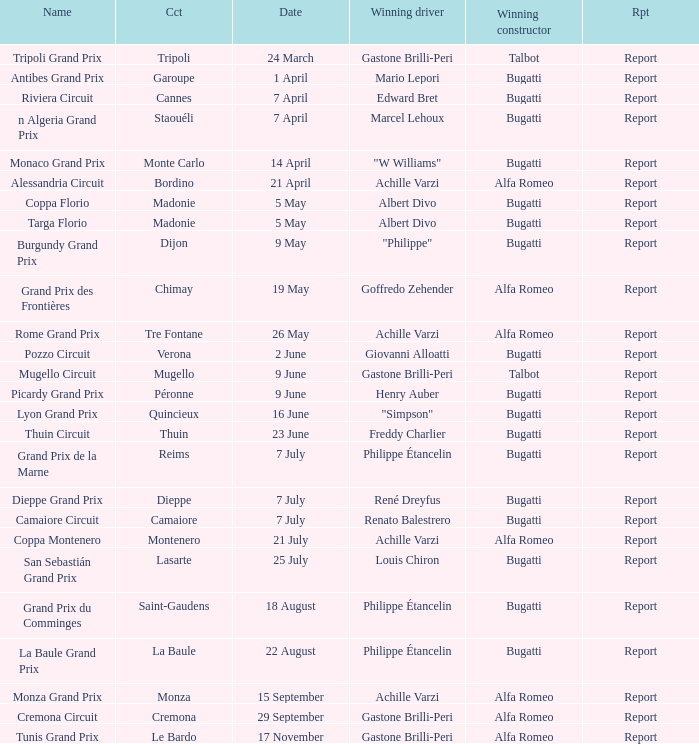What Winning driver has a Winning constructor of talbot? Gastone Brilli-Peri, Gastone Brilli-Peri. 